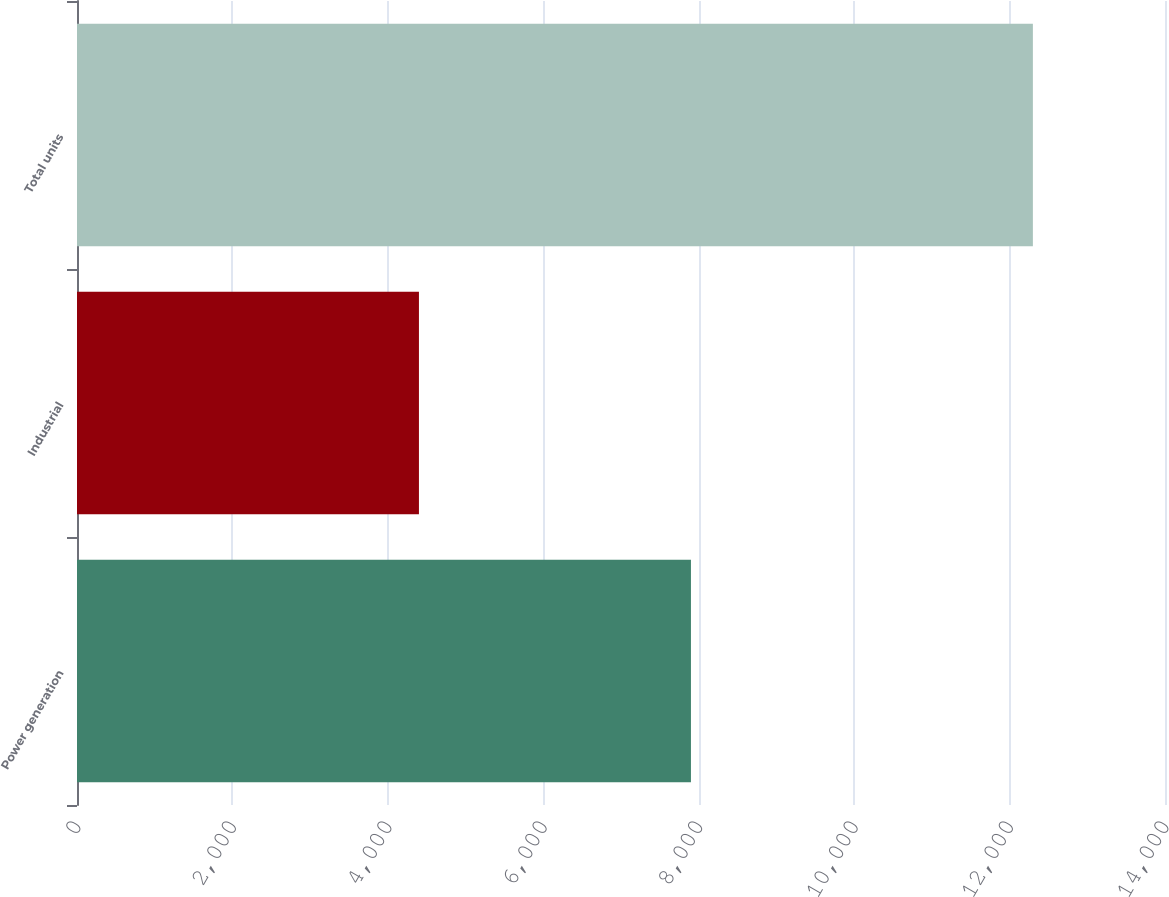Convert chart to OTSL. <chart><loc_0><loc_0><loc_500><loc_500><bar_chart><fcel>Power generation<fcel>Industrial<fcel>Total units<nl><fcel>7900<fcel>4400<fcel>12300<nl></chart> 